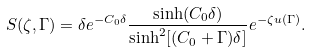<formula> <loc_0><loc_0><loc_500><loc_500>S ( \zeta , \Gamma ) = \delta e ^ { - C _ { 0 } \delta } \frac { \sinh ( C _ { 0 } \delta ) } { \sinh ^ { 2 } [ ( C _ { 0 } + \Gamma ) \delta ] } e ^ { - \zeta u ( \Gamma ) } .</formula> 